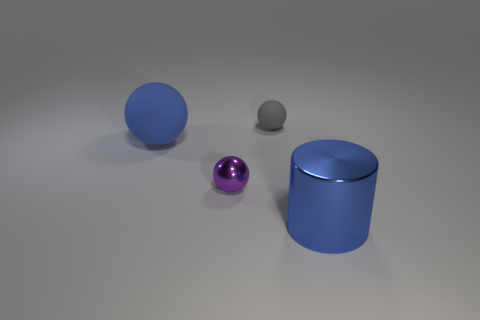Add 4 big metal cylinders. How many objects exist? 8 Subtract all cylinders. How many objects are left? 3 Subtract all tiny green metal cylinders. Subtract all matte things. How many objects are left? 2 Add 1 small gray rubber objects. How many small gray rubber objects are left? 2 Add 3 blue matte spheres. How many blue matte spheres exist? 4 Subtract 0 yellow cubes. How many objects are left? 4 